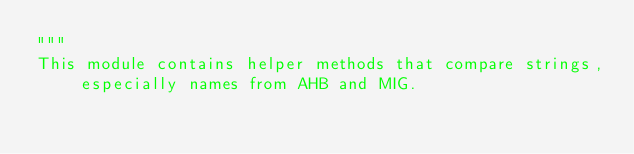Convert code to text. <code><loc_0><loc_0><loc_500><loc_500><_Python_>"""
This module contains helper methods that compare strings, especially names from AHB and MIG.</code> 